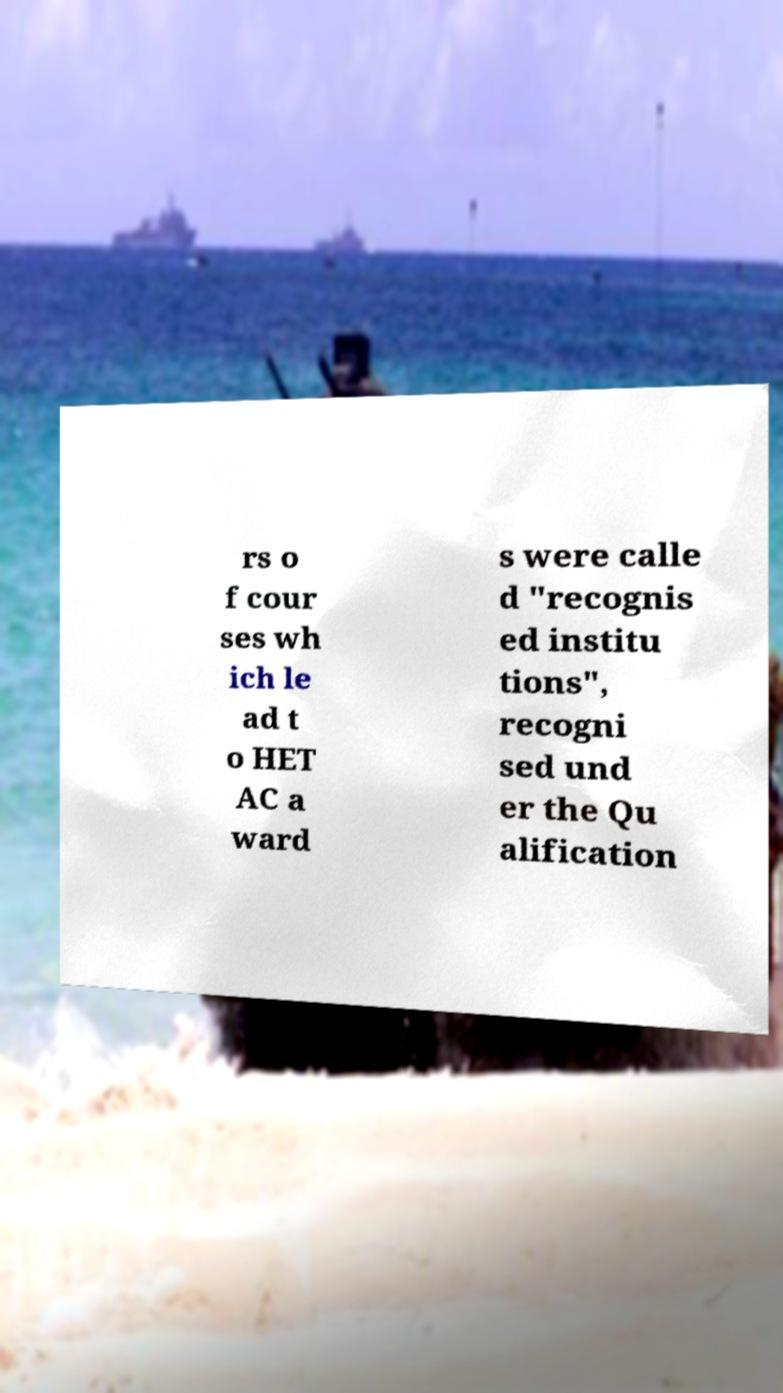Could you extract and type out the text from this image? rs o f cour ses wh ich le ad t o HET AC a ward s were calle d "recognis ed institu tions", recogni sed und er the Qu alification 